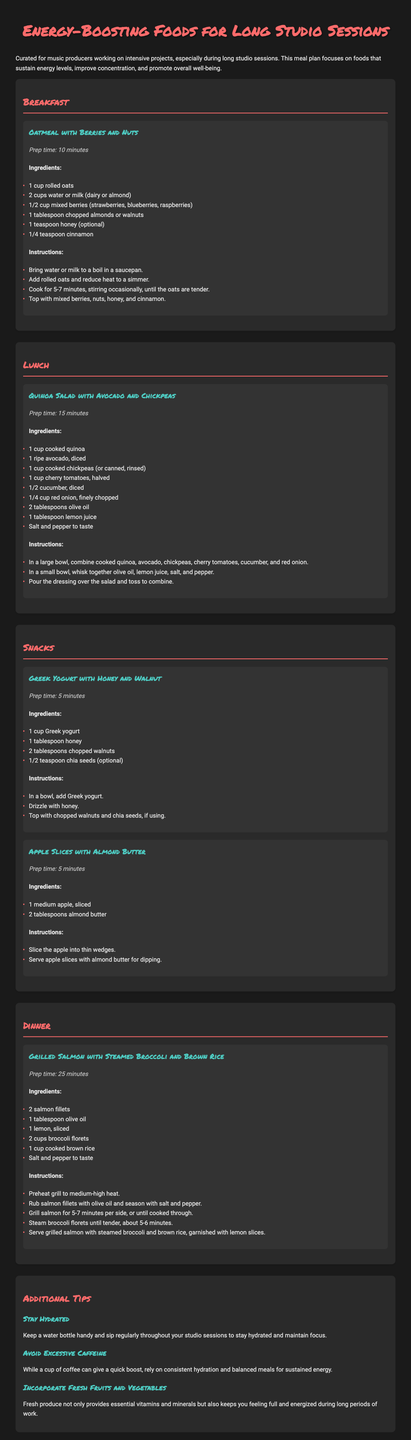What is the title of the document? The title of the document is presented at the top and states the focus of the meal plan.
Answer: Energy-Boosting Foods for Long Studio Sessions What are the ingredients for Oatmeal with Berries and Nuts? The ingredients for this recipe are listed in a bullet format under the corresponding recipe section.
Answer: 1 cup rolled oats, 2 cups water or milk, 1/2 cup mixed berries, 1 tablespoon chopped almonds or walnuts, 1 teaspoon honey, 1/4 teaspoon cinnamon How long does it take to prepare Grilled Salmon with Steamed Broccoli and Brown Rice? The preparation time is mentioned in the recipe section for Grilled Salmon.
Answer: 25 minutes What is recommended to stay hydrated? The additional tips provide advice on maintaining hydration during studio sessions.
Answer: Keep a water bottle handy Which meal includes chickpeas? The meal sections provide various recipes, one of which includes chickpeas.
Answer: Lunch What can you use instead of water in the oatmeal recipe? The document mentions an alternative liquid that can be used in place of water.
Answer: Milk (dairy or almond) How many types of snacks are listed? The snacks section contains two different snack recipes.
Answer: Two What does the tip about excessive caffeine suggest? The document includes a tip regarding caffeine consumption during studio sessions.
Answer: Rely on consistent hydration and balanced meals for sustained energy 